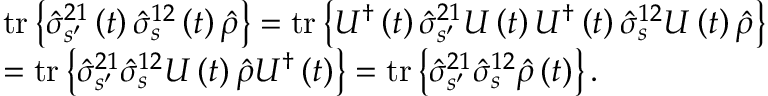<formula> <loc_0><loc_0><loc_500><loc_500>\begin{array} { r l } & { t r \left \{ \hat { \sigma } _ { s ^ { \prime } } ^ { 2 1 } \left ( t \right ) \hat { \sigma } _ { s } ^ { 1 2 } \left ( t \right ) \hat { \rho } \right \} = t r \left \{ U ^ { \dagger } \left ( t \right ) \hat { \sigma } _ { s ^ { \prime } } ^ { 2 1 } U \left ( t \right ) U ^ { \dagger } \left ( t \right ) \hat { \sigma } _ { s } ^ { 1 2 } U \left ( t \right ) \hat { \rho } \right \} } \\ & { = t r \left \{ \hat { \sigma } _ { s ^ { \prime } } ^ { 2 1 } \hat { \sigma } _ { s } ^ { 1 2 } U \left ( t \right ) \hat { \rho } U ^ { \dagger } \left ( t \right ) \right \} = t r \left \{ \hat { \sigma } _ { s ^ { \prime } } ^ { 2 1 } \hat { \sigma } _ { s } ^ { 1 2 } \hat { \rho } \left ( t \right ) \right \} . } \end{array}</formula> 